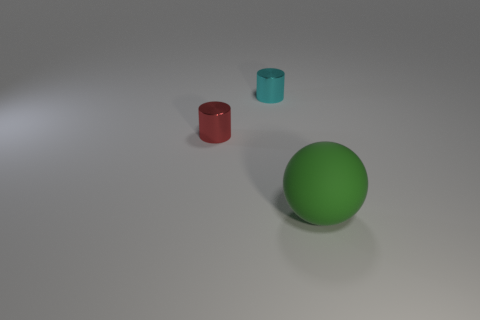How many objects are there and can you describe their shapes? There are three objects in the image. From left to right, there's a red cylinder, a green sphere, and a blue cylinder. 